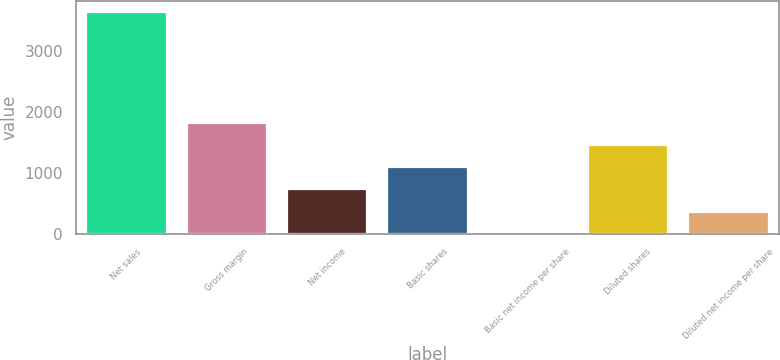Convert chart. <chart><loc_0><loc_0><loc_500><loc_500><bar_chart><fcel>Net sales<fcel>Gross margin<fcel>Net income<fcel>Basic shares<fcel>Basic net income per share<fcel>Diluted shares<fcel>Diluted net income per share<nl><fcel>3638<fcel>1819.25<fcel>727.97<fcel>1091.73<fcel>0.45<fcel>1455.49<fcel>364.21<nl></chart> 